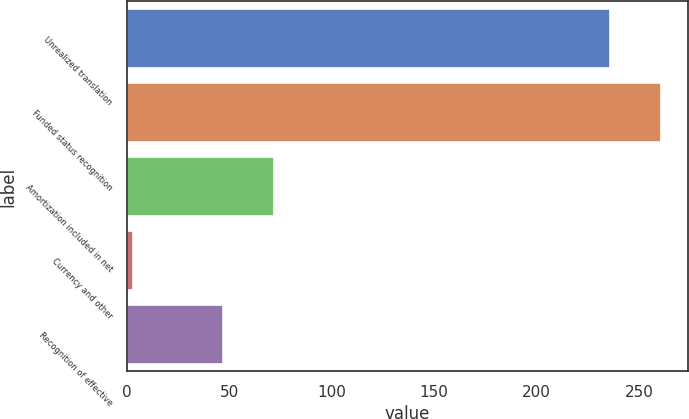<chart> <loc_0><loc_0><loc_500><loc_500><bar_chart><fcel>Unrealized translation<fcel>Funded status recognition<fcel>Amortization included in net<fcel>Currency and other<fcel>Recognition of effective<nl><fcel>236<fcel>260.9<fcel>71.9<fcel>3<fcel>47<nl></chart> 